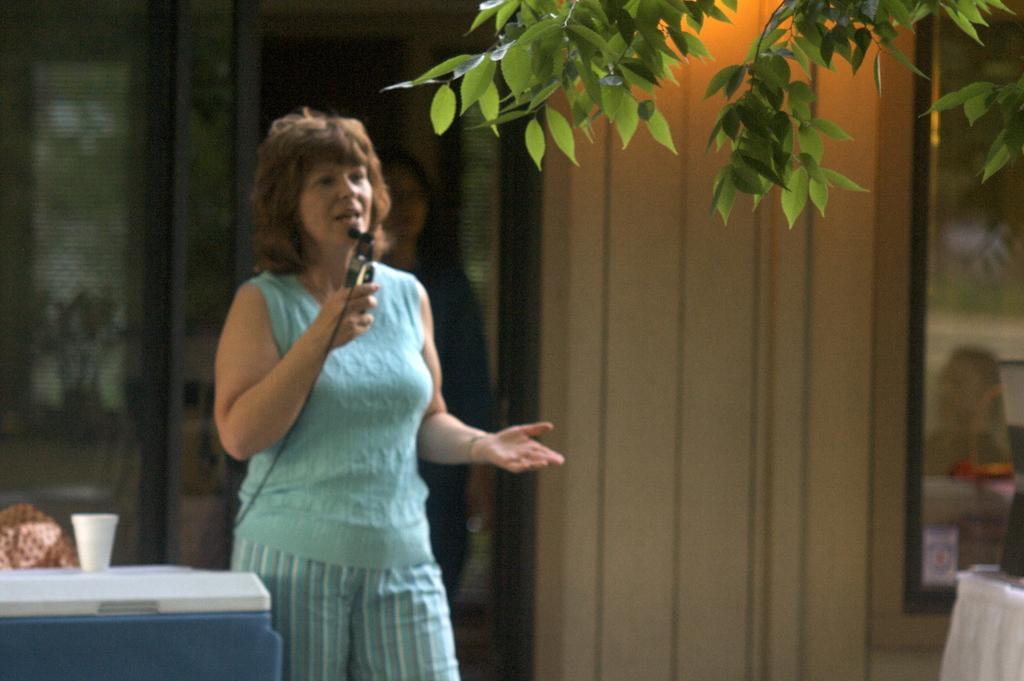Please provide a concise description of this image. In this image there is a woman standing and holding a mic and speaking in the center. On the right side there are leaves and on the left side there is a table and a white colour object on the table with the glass. In the background there is a woman and there is a wall. 